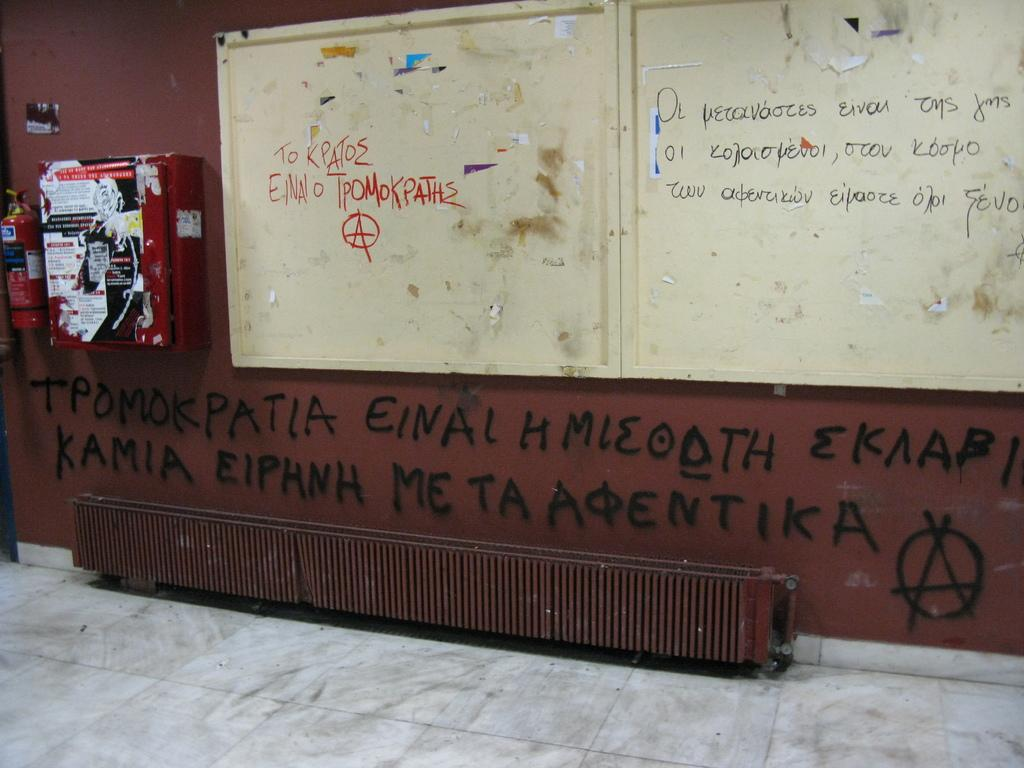<image>
Offer a succinct explanation of the picture presented. A brown wall has graffiti on it that includes the word einal. 